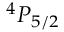Convert formula to latex. <formula><loc_0><loc_0><loc_500><loc_500>^ { 4 } P _ { 5 / 2 }</formula> 